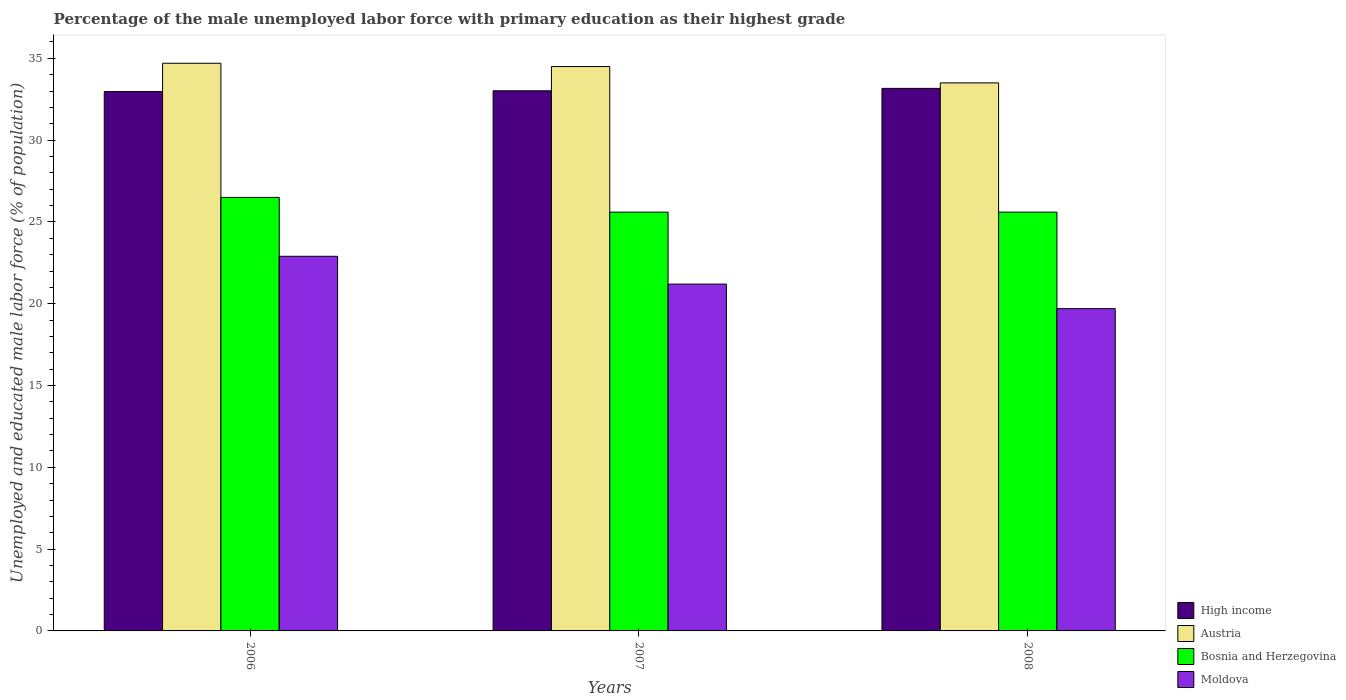How many different coloured bars are there?
Your answer should be very brief. 4. How many groups of bars are there?
Your answer should be very brief. 3. Are the number of bars per tick equal to the number of legend labels?
Ensure brevity in your answer.  Yes. How many bars are there on the 2nd tick from the right?
Ensure brevity in your answer.  4. What is the percentage of the unemployed male labor force with primary education in Austria in 2006?
Provide a succinct answer. 34.7. Across all years, what is the maximum percentage of the unemployed male labor force with primary education in High income?
Ensure brevity in your answer.  33.16. Across all years, what is the minimum percentage of the unemployed male labor force with primary education in Moldova?
Give a very brief answer. 19.7. In which year was the percentage of the unemployed male labor force with primary education in Austria minimum?
Provide a short and direct response. 2008. What is the total percentage of the unemployed male labor force with primary education in Bosnia and Herzegovina in the graph?
Offer a terse response. 77.7. What is the difference between the percentage of the unemployed male labor force with primary education in High income in 2007 and that in 2008?
Give a very brief answer. -0.15. What is the difference between the percentage of the unemployed male labor force with primary education in Austria in 2007 and the percentage of the unemployed male labor force with primary education in Moldova in 2006?
Your answer should be compact. 11.6. What is the average percentage of the unemployed male labor force with primary education in Austria per year?
Keep it short and to the point. 34.23. In the year 2008, what is the difference between the percentage of the unemployed male labor force with primary education in Austria and percentage of the unemployed male labor force with primary education in Bosnia and Herzegovina?
Give a very brief answer. 7.9. What is the ratio of the percentage of the unemployed male labor force with primary education in Moldova in 2007 to that in 2008?
Your response must be concise. 1.08. Is the difference between the percentage of the unemployed male labor force with primary education in Austria in 2006 and 2007 greater than the difference between the percentage of the unemployed male labor force with primary education in Bosnia and Herzegovina in 2006 and 2007?
Make the answer very short. No. What is the difference between the highest and the second highest percentage of the unemployed male labor force with primary education in Moldova?
Provide a succinct answer. 1.7. What is the difference between the highest and the lowest percentage of the unemployed male labor force with primary education in High income?
Make the answer very short. 0.2. Is the sum of the percentage of the unemployed male labor force with primary education in Moldova in 2006 and 2007 greater than the maximum percentage of the unemployed male labor force with primary education in High income across all years?
Make the answer very short. Yes. What does the 4th bar from the left in 2006 represents?
Make the answer very short. Moldova. What does the 1st bar from the right in 2008 represents?
Offer a very short reply. Moldova. How many bars are there?
Offer a terse response. 12. How many years are there in the graph?
Make the answer very short. 3. Does the graph contain any zero values?
Make the answer very short. No. Does the graph contain grids?
Offer a very short reply. No. How many legend labels are there?
Provide a succinct answer. 4. How are the legend labels stacked?
Provide a short and direct response. Vertical. What is the title of the graph?
Provide a succinct answer. Percentage of the male unemployed labor force with primary education as their highest grade. What is the label or title of the X-axis?
Keep it short and to the point. Years. What is the label or title of the Y-axis?
Provide a succinct answer. Unemployed and educated male labor force (% of population). What is the Unemployed and educated male labor force (% of population) of High income in 2006?
Keep it short and to the point. 32.97. What is the Unemployed and educated male labor force (% of population) in Austria in 2006?
Give a very brief answer. 34.7. What is the Unemployed and educated male labor force (% of population) in Moldova in 2006?
Give a very brief answer. 22.9. What is the Unemployed and educated male labor force (% of population) of High income in 2007?
Make the answer very short. 33.02. What is the Unemployed and educated male labor force (% of population) in Austria in 2007?
Give a very brief answer. 34.5. What is the Unemployed and educated male labor force (% of population) in Bosnia and Herzegovina in 2007?
Your answer should be very brief. 25.6. What is the Unemployed and educated male labor force (% of population) in Moldova in 2007?
Your response must be concise. 21.2. What is the Unemployed and educated male labor force (% of population) of High income in 2008?
Your response must be concise. 33.16. What is the Unemployed and educated male labor force (% of population) in Austria in 2008?
Offer a very short reply. 33.5. What is the Unemployed and educated male labor force (% of population) in Bosnia and Herzegovina in 2008?
Your answer should be compact. 25.6. What is the Unemployed and educated male labor force (% of population) in Moldova in 2008?
Ensure brevity in your answer.  19.7. Across all years, what is the maximum Unemployed and educated male labor force (% of population) of High income?
Give a very brief answer. 33.16. Across all years, what is the maximum Unemployed and educated male labor force (% of population) in Austria?
Provide a short and direct response. 34.7. Across all years, what is the maximum Unemployed and educated male labor force (% of population) in Moldova?
Make the answer very short. 22.9. Across all years, what is the minimum Unemployed and educated male labor force (% of population) of High income?
Your answer should be compact. 32.97. Across all years, what is the minimum Unemployed and educated male labor force (% of population) of Austria?
Provide a succinct answer. 33.5. Across all years, what is the minimum Unemployed and educated male labor force (% of population) of Bosnia and Herzegovina?
Make the answer very short. 25.6. Across all years, what is the minimum Unemployed and educated male labor force (% of population) in Moldova?
Your response must be concise. 19.7. What is the total Unemployed and educated male labor force (% of population) in High income in the graph?
Offer a very short reply. 99.15. What is the total Unemployed and educated male labor force (% of population) of Austria in the graph?
Offer a very short reply. 102.7. What is the total Unemployed and educated male labor force (% of population) of Bosnia and Herzegovina in the graph?
Your answer should be compact. 77.7. What is the total Unemployed and educated male labor force (% of population) of Moldova in the graph?
Give a very brief answer. 63.8. What is the difference between the Unemployed and educated male labor force (% of population) in High income in 2006 and that in 2007?
Provide a succinct answer. -0.05. What is the difference between the Unemployed and educated male labor force (% of population) in Bosnia and Herzegovina in 2006 and that in 2007?
Provide a short and direct response. 0.9. What is the difference between the Unemployed and educated male labor force (% of population) of High income in 2006 and that in 2008?
Ensure brevity in your answer.  -0.2. What is the difference between the Unemployed and educated male labor force (% of population) in Bosnia and Herzegovina in 2006 and that in 2008?
Your answer should be compact. 0.9. What is the difference between the Unemployed and educated male labor force (% of population) of High income in 2007 and that in 2008?
Offer a terse response. -0.15. What is the difference between the Unemployed and educated male labor force (% of population) in Bosnia and Herzegovina in 2007 and that in 2008?
Offer a terse response. 0. What is the difference between the Unemployed and educated male labor force (% of population) of Moldova in 2007 and that in 2008?
Provide a short and direct response. 1.5. What is the difference between the Unemployed and educated male labor force (% of population) of High income in 2006 and the Unemployed and educated male labor force (% of population) of Austria in 2007?
Offer a very short reply. -1.53. What is the difference between the Unemployed and educated male labor force (% of population) of High income in 2006 and the Unemployed and educated male labor force (% of population) of Bosnia and Herzegovina in 2007?
Give a very brief answer. 7.37. What is the difference between the Unemployed and educated male labor force (% of population) of High income in 2006 and the Unemployed and educated male labor force (% of population) of Moldova in 2007?
Give a very brief answer. 11.77. What is the difference between the Unemployed and educated male labor force (% of population) of Austria in 2006 and the Unemployed and educated male labor force (% of population) of Bosnia and Herzegovina in 2007?
Ensure brevity in your answer.  9.1. What is the difference between the Unemployed and educated male labor force (% of population) of High income in 2006 and the Unemployed and educated male labor force (% of population) of Austria in 2008?
Your answer should be very brief. -0.53. What is the difference between the Unemployed and educated male labor force (% of population) of High income in 2006 and the Unemployed and educated male labor force (% of population) of Bosnia and Herzegovina in 2008?
Ensure brevity in your answer.  7.37. What is the difference between the Unemployed and educated male labor force (% of population) in High income in 2006 and the Unemployed and educated male labor force (% of population) in Moldova in 2008?
Offer a very short reply. 13.27. What is the difference between the Unemployed and educated male labor force (% of population) in Austria in 2006 and the Unemployed and educated male labor force (% of population) in Bosnia and Herzegovina in 2008?
Provide a succinct answer. 9.1. What is the difference between the Unemployed and educated male labor force (% of population) in Austria in 2006 and the Unemployed and educated male labor force (% of population) in Moldova in 2008?
Make the answer very short. 15. What is the difference between the Unemployed and educated male labor force (% of population) of Bosnia and Herzegovina in 2006 and the Unemployed and educated male labor force (% of population) of Moldova in 2008?
Your answer should be very brief. 6.8. What is the difference between the Unemployed and educated male labor force (% of population) in High income in 2007 and the Unemployed and educated male labor force (% of population) in Austria in 2008?
Your answer should be very brief. -0.48. What is the difference between the Unemployed and educated male labor force (% of population) in High income in 2007 and the Unemployed and educated male labor force (% of population) in Bosnia and Herzegovina in 2008?
Offer a terse response. 7.42. What is the difference between the Unemployed and educated male labor force (% of population) of High income in 2007 and the Unemployed and educated male labor force (% of population) of Moldova in 2008?
Ensure brevity in your answer.  13.32. What is the difference between the Unemployed and educated male labor force (% of population) of Austria in 2007 and the Unemployed and educated male labor force (% of population) of Moldova in 2008?
Your response must be concise. 14.8. What is the average Unemployed and educated male labor force (% of population) of High income per year?
Give a very brief answer. 33.05. What is the average Unemployed and educated male labor force (% of population) in Austria per year?
Keep it short and to the point. 34.23. What is the average Unemployed and educated male labor force (% of population) of Bosnia and Herzegovina per year?
Offer a very short reply. 25.9. What is the average Unemployed and educated male labor force (% of population) of Moldova per year?
Your response must be concise. 21.27. In the year 2006, what is the difference between the Unemployed and educated male labor force (% of population) of High income and Unemployed and educated male labor force (% of population) of Austria?
Your answer should be compact. -1.73. In the year 2006, what is the difference between the Unemployed and educated male labor force (% of population) of High income and Unemployed and educated male labor force (% of population) of Bosnia and Herzegovina?
Offer a terse response. 6.47. In the year 2006, what is the difference between the Unemployed and educated male labor force (% of population) of High income and Unemployed and educated male labor force (% of population) of Moldova?
Your answer should be very brief. 10.07. In the year 2006, what is the difference between the Unemployed and educated male labor force (% of population) in Austria and Unemployed and educated male labor force (% of population) in Bosnia and Herzegovina?
Ensure brevity in your answer.  8.2. In the year 2006, what is the difference between the Unemployed and educated male labor force (% of population) of Austria and Unemployed and educated male labor force (% of population) of Moldova?
Give a very brief answer. 11.8. In the year 2006, what is the difference between the Unemployed and educated male labor force (% of population) in Bosnia and Herzegovina and Unemployed and educated male labor force (% of population) in Moldova?
Provide a short and direct response. 3.6. In the year 2007, what is the difference between the Unemployed and educated male labor force (% of population) of High income and Unemployed and educated male labor force (% of population) of Austria?
Your response must be concise. -1.48. In the year 2007, what is the difference between the Unemployed and educated male labor force (% of population) of High income and Unemployed and educated male labor force (% of population) of Bosnia and Herzegovina?
Ensure brevity in your answer.  7.42. In the year 2007, what is the difference between the Unemployed and educated male labor force (% of population) of High income and Unemployed and educated male labor force (% of population) of Moldova?
Ensure brevity in your answer.  11.82. In the year 2008, what is the difference between the Unemployed and educated male labor force (% of population) in High income and Unemployed and educated male labor force (% of population) in Austria?
Give a very brief answer. -0.34. In the year 2008, what is the difference between the Unemployed and educated male labor force (% of population) of High income and Unemployed and educated male labor force (% of population) of Bosnia and Herzegovina?
Offer a terse response. 7.56. In the year 2008, what is the difference between the Unemployed and educated male labor force (% of population) of High income and Unemployed and educated male labor force (% of population) of Moldova?
Provide a succinct answer. 13.46. In the year 2008, what is the difference between the Unemployed and educated male labor force (% of population) in Austria and Unemployed and educated male labor force (% of population) in Bosnia and Herzegovina?
Ensure brevity in your answer.  7.9. In the year 2008, what is the difference between the Unemployed and educated male labor force (% of population) of Austria and Unemployed and educated male labor force (% of population) of Moldova?
Make the answer very short. 13.8. In the year 2008, what is the difference between the Unemployed and educated male labor force (% of population) of Bosnia and Herzegovina and Unemployed and educated male labor force (% of population) of Moldova?
Make the answer very short. 5.9. What is the ratio of the Unemployed and educated male labor force (% of population) in Austria in 2006 to that in 2007?
Offer a very short reply. 1.01. What is the ratio of the Unemployed and educated male labor force (% of population) in Bosnia and Herzegovina in 2006 to that in 2007?
Make the answer very short. 1.04. What is the ratio of the Unemployed and educated male labor force (% of population) of Moldova in 2006 to that in 2007?
Provide a short and direct response. 1.08. What is the ratio of the Unemployed and educated male labor force (% of population) in Austria in 2006 to that in 2008?
Provide a succinct answer. 1.04. What is the ratio of the Unemployed and educated male labor force (% of population) in Bosnia and Herzegovina in 2006 to that in 2008?
Ensure brevity in your answer.  1.04. What is the ratio of the Unemployed and educated male labor force (% of population) in Moldova in 2006 to that in 2008?
Your response must be concise. 1.16. What is the ratio of the Unemployed and educated male labor force (% of population) of High income in 2007 to that in 2008?
Provide a succinct answer. 1. What is the ratio of the Unemployed and educated male labor force (% of population) in Austria in 2007 to that in 2008?
Your response must be concise. 1.03. What is the ratio of the Unemployed and educated male labor force (% of population) of Bosnia and Herzegovina in 2007 to that in 2008?
Your answer should be very brief. 1. What is the ratio of the Unemployed and educated male labor force (% of population) of Moldova in 2007 to that in 2008?
Ensure brevity in your answer.  1.08. What is the difference between the highest and the second highest Unemployed and educated male labor force (% of population) in High income?
Ensure brevity in your answer.  0.15. What is the difference between the highest and the second highest Unemployed and educated male labor force (% of population) of Austria?
Make the answer very short. 0.2. What is the difference between the highest and the second highest Unemployed and educated male labor force (% of population) in Moldova?
Provide a short and direct response. 1.7. What is the difference between the highest and the lowest Unemployed and educated male labor force (% of population) in High income?
Your answer should be very brief. 0.2. What is the difference between the highest and the lowest Unemployed and educated male labor force (% of population) of Bosnia and Herzegovina?
Give a very brief answer. 0.9. What is the difference between the highest and the lowest Unemployed and educated male labor force (% of population) of Moldova?
Provide a succinct answer. 3.2. 